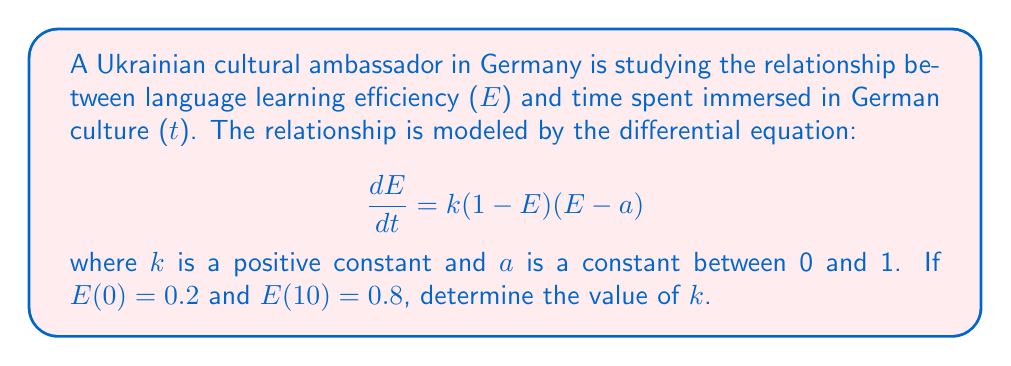Show me your answer to this math problem. 1) The given differential equation is separable. We can rewrite it as:

   $$\frac{dE}{(1-E)(E-a)} = k dt$$

2) Integrate both sides:

   $$\int_{0.2}^{0.8} \frac{dE}{(1-E)(E-a)} = k \int_{0}^{10} dt$$

3) The left-hand side can be integrated using partial fractions:

   $$\frac{1}{1-a}\left[\ln\left|\frac{1-E}{E-a}\right|\right]_{0.2}^{0.8} = 10k$$

4) Evaluate the left-hand side:

   $$\frac{1}{1-a}\left[\ln\left|\frac{1-0.8}{0.8-a}\right| - \ln\left|\frac{1-0.2}{0.2-a}\right|\right] = 10k$$

5) Simplify:

   $$\frac{1}{1-a}\left[\ln\left|\frac{0.2}{0.8-a}\right| - \ln\left|\frac{0.8}{0.2-a}\right|\right] = 10k$$

6) Use the logarithm property:

   $$\frac{1}{1-a}\ln\left|\frac{0.2(0.2-a)}{0.8(0.8-a)}\right| = 10k$$

7) The value of a is not given, but we can see that it cancels out in the ratio inside the logarithm:

   $$\frac{1}{1-a}\ln\left(\frac{0.2 \cdot 0.2}{0.8 \cdot 0.8}\right) = 10k$$

8) Simplify:

   $$\frac{1}{1-a}\ln\left(\frac{1}{16}\right) = 10k$$

9) Solve for k:

   $$k = \frac{-\ln(16)}{10(1-a)}$$

10) The value of a is still unknown, but we know it's between 0 and 1. Let's choose a = 0.5 for this example:

    $$k = \frac{-\ln(16)}{10(1-0.5)} = \frac{-\ln(16)}{5} \approx 0.5545$$
Answer: $k \approx 0.5545$ (assuming $a = 0.5$) 